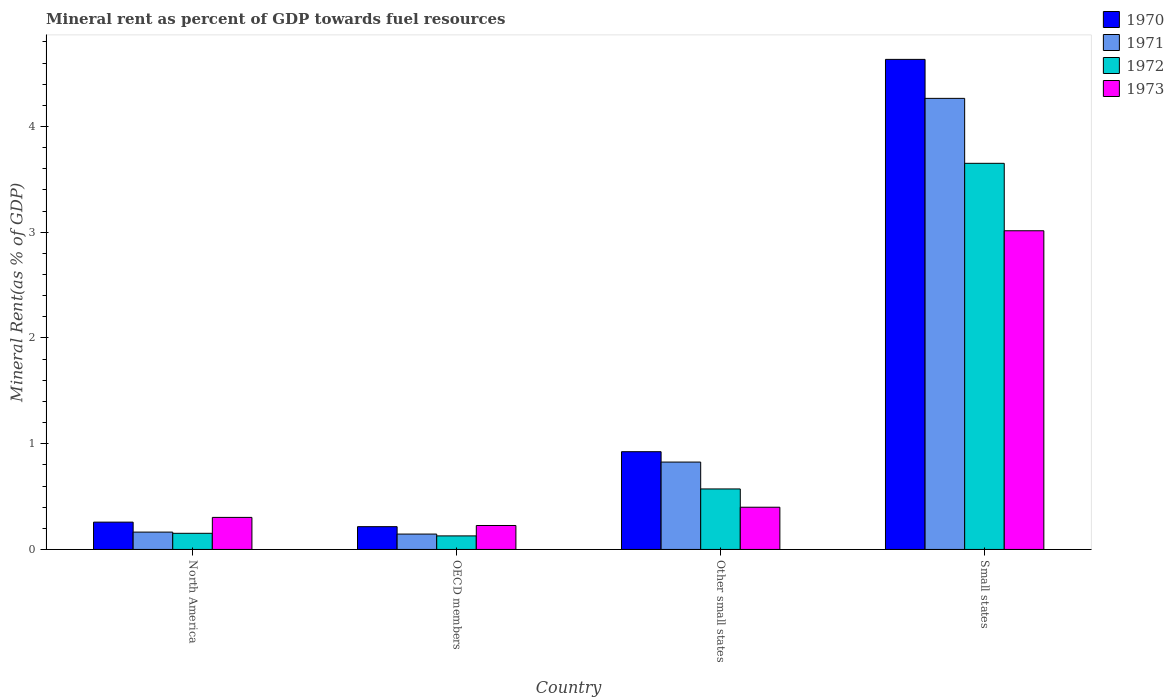How many different coloured bars are there?
Give a very brief answer. 4. How many groups of bars are there?
Provide a short and direct response. 4. Are the number of bars per tick equal to the number of legend labels?
Your answer should be very brief. Yes. How many bars are there on the 4th tick from the right?
Your response must be concise. 4. What is the label of the 1st group of bars from the left?
Provide a succinct answer. North America. In how many cases, is the number of bars for a given country not equal to the number of legend labels?
Provide a short and direct response. 0. What is the mineral rent in 1973 in North America?
Your answer should be very brief. 0.3. Across all countries, what is the maximum mineral rent in 1971?
Keep it short and to the point. 4.27. Across all countries, what is the minimum mineral rent in 1972?
Ensure brevity in your answer.  0.13. In which country was the mineral rent in 1971 maximum?
Offer a terse response. Small states. In which country was the mineral rent in 1970 minimum?
Keep it short and to the point. OECD members. What is the total mineral rent in 1972 in the graph?
Make the answer very short. 4.5. What is the difference between the mineral rent in 1971 in OECD members and that in Small states?
Provide a short and direct response. -4.12. What is the difference between the mineral rent in 1973 in North America and the mineral rent in 1971 in OECD members?
Give a very brief answer. 0.16. What is the average mineral rent in 1971 per country?
Offer a very short reply. 1.35. What is the difference between the mineral rent of/in 1972 and mineral rent of/in 1970 in North America?
Ensure brevity in your answer.  -0.11. In how many countries, is the mineral rent in 1971 greater than 1.2 %?
Ensure brevity in your answer.  1. What is the ratio of the mineral rent in 1973 in North America to that in Small states?
Your answer should be very brief. 0.1. Is the mineral rent in 1970 in North America less than that in OECD members?
Your answer should be compact. No. Is the difference between the mineral rent in 1972 in OECD members and Small states greater than the difference between the mineral rent in 1970 in OECD members and Small states?
Your answer should be very brief. Yes. What is the difference between the highest and the second highest mineral rent in 1971?
Keep it short and to the point. 0.66. What is the difference between the highest and the lowest mineral rent in 1973?
Your response must be concise. 2.79. Is the sum of the mineral rent in 1971 in OECD members and Small states greater than the maximum mineral rent in 1972 across all countries?
Provide a short and direct response. Yes. Is it the case that in every country, the sum of the mineral rent in 1973 and mineral rent in 1970 is greater than the sum of mineral rent in 1971 and mineral rent in 1972?
Provide a short and direct response. No. Is it the case that in every country, the sum of the mineral rent in 1972 and mineral rent in 1971 is greater than the mineral rent in 1973?
Give a very brief answer. Yes. Are all the bars in the graph horizontal?
Make the answer very short. No. How many countries are there in the graph?
Give a very brief answer. 4. What is the difference between two consecutive major ticks on the Y-axis?
Provide a short and direct response. 1. Are the values on the major ticks of Y-axis written in scientific E-notation?
Ensure brevity in your answer.  No. Does the graph contain any zero values?
Your answer should be compact. No. Does the graph contain grids?
Keep it short and to the point. No. What is the title of the graph?
Ensure brevity in your answer.  Mineral rent as percent of GDP towards fuel resources. Does "1962" appear as one of the legend labels in the graph?
Keep it short and to the point. No. What is the label or title of the X-axis?
Provide a succinct answer. Country. What is the label or title of the Y-axis?
Keep it short and to the point. Mineral Rent(as % of GDP). What is the Mineral Rent(as % of GDP) of 1970 in North America?
Provide a short and direct response. 0.26. What is the Mineral Rent(as % of GDP) of 1971 in North America?
Your response must be concise. 0.16. What is the Mineral Rent(as % of GDP) in 1972 in North America?
Your answer should be compact. 0.15. What is the Mineral Rent(as % of GDP) of 1973 in North America?
Provide a short and direct response. 0.3. What is the Mineral Rent(as % of GDP) in 1970 in OECD members?
Make the answer very short. 0.22. What is the Mineral Rent(as % of GDP) of 1971 in OECD members?
Ensure brevity in your answer.  0.15. What is the Mineral Rent(as % of GDP) in 1972 in OECD members?
Your answer should be very brief. 0.13. What is the Mineral Rent(as % of GDP) in 1973 in OECD members?
Provide a succinct answer. 0.23. What is the Mineral Rent(as % of GDP) of 1970 in Other small states?
Offer a terse response. 0.92. What is the Mineral Rent(as % of GDP) of 1971 in Other small states?
Keep it short and to the point. 0.83. What is the Mineral Rent(as % of GDP) of 1972 in Other small states?
Provide a succinct answer. 0.57. What is the Mineral Rent(as % of GDP) of 1973 in Other small states?
Give a very brief answer. 0.4. What is the Mineral Rent(as % of GDP) in 1970 in Small states?
Your answer should be very brief. 4.63. What is the Mineral Rent(as % of GDP) of 1971 in Small states?
Ensure brevity in your answer.  4.27. What is the Mineral Rent(as % of GDP) in 1972 in Small states?
Your answer should be very brief. 3.65. What is the Mineral Rent(as % of GDP) of 1973 in Small states?
Ensure brevity in your answer.  3.01. Across all countries, what is the maximum Mineral Rent(as % of GDP) in 1970?
Make the answer very short. 4.63. Across all countries, what is the maximum Mineral Rent(as % of GDP) of 1971?
Keep it short and to the point. 4.27. Across all countries, what is the maximum Mineral Rent(as % of GDP) in 1972?
Your response must be concise. 3.65. Across all countries, what is the maximum Mineral Rent(as % of GDP) of 1973?
Provide a short and direct response. 3.01. Across all countries, what is the minimum Mineral Rent(as % of GDP) of 1970?
Your answer should be very brief. 0.22. Across all countries, what is the minimum Mineral Rent(as % of GDP) of 1971?
Provide a short and direct response. 0.15. Across all countries, what is the minimum Mineral Rent(as % of GDP) in 1972?
Give a very brief answer. 0.13. Across all countries, what is the minimum Mineral Rent(as % of GDP) in 1973?
Provide a short and direct response. 0.23. What is the total Mineral Rent(as % of GDP) of 1970 in the graph?
Your answer should be very brief. 6.03. What is the total Mineral Rent(as % of GDP) in 1971 in the graph?
Provide a short and direct response. 5.4. What is the total Mineral Rent(as % of GDP) of 1972 in the graph?
Your answer should be compact. 4.5. What is the total Mineral Rent(as % of GDP) in 1973 in the graph?
Your answer should be compact. 3.94. What is the difference between the Mineral Rent(as % of GDP) of 1970 in North America and that in OECD members?
Your response must be concise. 0.04. What is the difference between the Mineral Rent(as % of GDP) in 1971 in North America and that in OECD members?
Offer a very short reply. 0.02. What is the difference between the Mineral Rent(as % of GDP) of 1972 in North America and that in OECD members?
Give a very brief answer. 0.02. What is the difference between the Mineral Rent(as % of GDP) of 1973 in North America and that in OECD members?
Your answer should be very brief. 0.08. What is the difference between the Mineral Rent(as % of GDP) of 1970 in North America and that in Other small states?
Make the answer very short. -0.67. What is the difference between the Mineral Rent(as % of GDP) in 1971 in North America and that in Other small states?
Give a very brief answer. -0.66. What is the difference between the Mineral Rent(as % of GDP) in 1972 in North America and that in Other small states?
Provide a short and direct response. -0.42. What is the difference between the Mineral Rent(as % of GDP) in 1973 in North America and that in Other small states?
Ensure brevity in your answer.  -0.1. What is the difference between the Mineral Rent(as % of GDP) of 1970 in North America and that in Small states?
Provide a short and direct response. -4.38. What is the difference between the Mineral Rent(as % of GDP) in 1971 in North America and that in Small states?
Give a very brief answer. -4.1. What is the difference between the Mineral Rent(as % of GDP) of 1972 in North America and that in Small states?
Keep it short and to the point. -3.5. What is the difference between the Mineral Rent(as % of GDP) in 1973 in North America and that in Small states?
Provide a succinct answer. -2.71. What is the difference between the Mineral Rent(as % of GDP) of 1970 in OECD members and that in Other small states?
Your answer should be compact. -0.71. What is the difference between the Mineral Rent(as % of GDP) in 1971 in OECD members and that in Other small states?
Offer a very short reply. -0.68. What is the difference between the Mineral Rent(as % of GDP) in 1972 in OECD members and that in Other small states?
Your answer should be very brief. -0.44. What is the difference between the Mineral Rent(as % of GDP) of 1973 in OECD members and that in Other small states?
Make the answer very short. -0.17. What is the difference between the Mineral Rent(as % of GDP) of 1970 in OECD members and that in Small states?
Provide a succinct answer. -4.42. What is the difference between the Mineral Rent(as % of GDP) of 1971 in OECD members and that in Small states?
Ensure brevity in your answer.  -4.12. What is the difference between the Mineral Rent(as % of GDP) of 1972 in OECD members and that in Small states?
Offer a terse response. -3.52. What is the difference between the Mineral Rent(as % of GDP) in 1973 in OECD members and that in Small states?
Give a very brief answer. -2.79. What is the difference between the Mineral Rent(as % of GDP) in 1970 in Other small states and that in Small states?
Offer a very short reply. -3.71. What is the difference between the Mineral Rent(as % of GDP) in 1971 in Other small states and that in Small states?
Offer a terse response. -3.44. What is the difference between the Mineral Rent(as % of GDP) in 1972 in Other small states and that in Small states?
Your answer should be compact. -3.08. What is the difference between the Mineral Rent(as % of GDP) of 1973 in Other small states and that in Small states?
Your answer should be compact. -2.61. What is the difference between the Mineral Rent(as % of GDP) of 1970 in North America and the Mineral Rent(as % of GDP) of 1971 in OECD members?
Your answer should be compact. 0.11. What is the difference between the Mineral Rent(as % of GDP) in 1970 in North America and the Mineral Rent(as % of GDP) in 1972 in OECD members?
Give a very brief answer. 0.13. What is the difference between the Mineral Rent(as % of GDP) in 1970 in North America and the Mineral Rent(as % of GDP) in 1973 in OECD members?
Your response must be concise. 0.03. What is the difference between the Mineral Rent(as % of GDP) in 1971 in North America and the Mineral Rent(as % of GDP) in 1972 in OECD members?
Your response must be concise. 0.04. What is the difference between the Mineral Rent(as % of GDP) of 1971 in North America and the Mineral Rent(as % of GDP) of 1973 in OECD members?
Provide a short and direct response. -0.06. What is the difference between the Mineral Rent(as % of GDP) in 1972 in North America and the Mineral Rent(as % of GDP) in 1973 in OECD members?
Your answer should be compact. -0.07. What is the difference between the Mineral Rent(as % of GDP) of 1970 in North America and the Mineral Rent(as % of GDP) of 1971 in Other small states?
Make the answer very short. -0.57. What is the difference between the Mineral Rent(as % of GDP) in 1970 in North America and the Mineral Rent(as % of GDP) in 1972 in Other small states?
Provide a succinct answer. -0.31. What is the difference between the Mineral Rent(as % of GDP) of 1970 in North America and the Mineral Rent(as % of GDP) of 1973 in Other small states?
Provide a short and direct response. -0.14. What is the difference between the Mineral Rent(as % of GDP) of 1971 in North America and the Mineral Rent(as % of GDP) of 1972 in Other small states?
Offer a terse response. -0.41. What is the difference between the Mineral Rent(as % of GDP) of 1971 in North America and the Mineral Rent(as % of GDP) of 1973 in Other small states?
Ensure brevity in your answer.  -0.24. What is the difference between the Mineral Rent(as % of GDP) in 1972 in North America and the Mineral Rent(as % of GDP) in 1973 in Other small states?
Your response must be concise. -0.25. What is the difference between the Mineral Rent(as % of GDP) of 1970 in North America and the Mineral Rent(as % of GDP) of 1971 in Small states?
Keep it short and to the point. -4.01. What is the difference between the Mineral Rent(as % of GDP) in 1970 in North America and the Mineral Rent(as % of GDP) in 1972 in Small states?
Your answer should be very brief. -3.39. What is the difference between the Mineral Rent(as % of GDP) in 1970 in North America and the Mineral Rent(as % of GDP) in 1973 in Small states?
Your answer should be compact. -2.76. What is the difference between the Mineral Rent(as % of GDP) in 1971 in North America and the Mineral Rent(as % of GDP) in 1972 in Small states?
Make the answer very short. -3.49. What is the difference between the Mineral Rent(as % of GDP) of 1971 in North America and the Mineral Rent(as % of GDP) of 1973 in Small states?
Keep it short and to the point. -2.85. What is the difference between the Mineral Rent(as % of GDP) of 1972 in North America and the Mineral Rent(as % of GDP) of 1973 in Small states?
Offer a very short reply. -2.86. What is the difference between the Mineral Rent(as % of GDP) in 1970 in OECD members and the Mineral Rent(as % of GDP) in 1971 in Other small states?
Ensure brevity in your answer.  -0.61. What is the difference between the Mineral Rent(as % of GDP) of 1970 in OECD members and the Mineral Rent(as % of GDP) of 1972 in Other small states?
Keep it short and to the point. -0.36. What is the difference between the Mineral Rent(as % of GDP) of 1970 in OECD members and the Mineral Rent(as % of GDP) of 1973 in Other small states?
Your answer should be compact. -0.18. What is the difference between the Mineral Rent(as % of GDP) of 1971 in OECD members and the Mineral Rent(as % of GDP) of 1972 in Other small states?
Keep it short and to the point. -0.43. What is the difference between the Mineral Rent(as % of GDP) of 1971 in OECD members and the Mineral Rent(as % of GDP) of 1973 in Other small states?
Offer a terse response. -0.25. What is the difference between the Mineral Rent(as % of GDP) in 1972 in OECD members and the Mineral Rent(as % of GDP) in 1973 in Other small states?
Provide a short and direct response. -0.27. What is the difference between the Mineral Rent(as % of GDP) of 1970 in OECD members and the Mineral Rent(as % of GDP) of 1971 in Small states?
Offer a very short reply. -4.05. What is the difference between the Mineral Rent(as % of GDP) in 1970 in OECD members and the Mineral Rent(as % of GDP) in 1972 in Small states?
Offer a very short reply. -3.44. What is the difference between the Mineral Rent(as % of GDP) in 1970 in OECD members and the Mineral Rent(as % of GDP) in 1973 in Small states?
Your answer should be compact. -2.8. What is the difference between the Mineral Rent(as % of GDP) in 1971 in OECD members and the Mineral Rent(as % of GDP) in 1972 in Small states?
Provide a short and direct response. -3.51. What is the difference between the Mineral Rent(as % of GDP) in 1971 in OECD members and the Mineral Rent(as % of GDP) in 1973 in Small states?
Your answer should be very brief. -2.87. What is the difference between the Mineral Rent(as % of GDP) in 1972 in OECD members and the Mineral Rent(as % of GDP) in 1973 in Small states?
Your answer should be very brief. -2.89. What is the difference between the Mineral Rent(as % of GDP) in 1970 in Other small states and the Mineral Rent(as % of GDP) in 1971 in Small states?
Keep it short and to the point. -3.34. What is the difference between the Mineral Rent(as % of GDP) of 1970 in Other small states and the Mineral Rent(as % of GDP) of 1972 in Small states?
Give a very brief answer. -2.73. What is the difference between the Mineral Rent(as % of GDP) of 1970 in Other small states and the Mineral Rent(as % of GDP) of 1973 in Small states?
Offer a very short reply. -2.09. What is the difference between the Mineral Rent(as % of GDP) in 1971 in Other small states and the Mineral Rent(as % of GDP) in 1972 in Small states?
Your answer should be very brief. -2.83. What is the difference between the Mineral Rent(as % of GDP) of 1971 in Other small states and the Mineral Rent(as % of GDP) of 1973 in Small states?
Give a very brief answer. -2.19. What is the difference between the Mineral Rent(as % of GDP) of 1972 in Other small states and the Mineral Rent(as % of GDP) of 1973 in Small states?
Your answer should be compact. -2.44. What is the average Mineral Rent(as % of GDP) in 1970 per country?
Provide a succinct answer. 1.51. What is the average Mineral Rent(as % of GDP) of 1971 per country?
Provide a short and direct response. 1.35. What is the average Mineral Rent(as % of GDP) in 1972 per country?
Ensure brevity in your answer.  1.13. What is the average Mineral Rent(as % of GDP) of 1973 per country?
Ensure brevity in your answer.  0.99. What is the difference between the Mineral Rent(as % of GDP) in 1970 and Mineral Rent(as % of GDP) in 1971 in North America?
Ensure brevity in your answer.  0.09. What is the difference between the Mineral Rent(as % of GDP) in 1970 and Mineral Rent(as % of GDP) in 1972 in North America?
Keep it short and to the point. 0.11. What is the difference between the Mineral Rent(as % of GDP) in 1970 and Mineral Rent(as % of GDP) in 1973 in North America?
Offer a very short reply. -0.04. What is the difference between the Mineral Rent(as % of GDP) of 1971 and Mineral Rent(as % of GDP) of 1972 in North America?
Offer a terse response. 0.01. What is the difference between the Mineral Rent(as % of GDP) of 1971 and Mineral Rent(as % of GDP) of 1973 in North America?
Your response must be concise. -0.14. What is the difference between the Mineral Rent(as % of GDP) of 1972 and Mineral Rent(as % of GDP) of 1973 in North America?
Provide a succinct answer. -0.15. What is the difference between the Mineral Rent(as % of GDP) in 1970 and Mineral Rent(as % of GDP) in 1971 in OECD members?
Provide a succinct answer. 0.07. What is the difference between the Mineral Rent(as % of GDP) of 1970 and Mineral Rent(as % of GDP) of 1972 in OECD members?
Keep it short and to the point. 0.09. What is the difference between the Mineral Rent(as % of GDP) of 1970 and Mineral Rent(as % of GDP) of 1973 in OECD members?
Your response must be concise. -0.01. What is the difference between the Mineral Rent(as % of GDP) of 1971 and Mineral Rent(as % of GDP) of 1972 in OECD members?
Provide a succinct answer. 0.02. What is the difference between the Mineral Rent(as % of GDP) in 1971 and Mineral Rent(as % of GDP) in 1973 in OECD members?
Keep it short and to the point. -0.08. What is the difference between the Mineral Rent(as % of GDP) of 1972 and Mineral Rent(as % of GDP) of 1973 in OECD members?
Keep it short and to the point. -0.1. What is the difference between the Mineral Rent(as % of GDP) in 1970 and Mineral Rent(as % of GDP) in 1971 in Other small states?
Provide a short and direct response. 0.1. What is the difference between the Mineral Rent(as % of GDP) in 1970 and Mineral Rent(as % of GDP) in 1972 in Other small states?
Offer a very short reply. 0.35. What is the difference between the Mineral Rent(as % of GDP) of 1970 and Mineral Rent(as % of GDP) of 1973 in Other small states?
Your answer should be compact. 0.53. What is the difference between the Mineral Rent(as % of GDP) of 1971 and Mineral Rent(as % of GDP) of 1972 in Other small states?
Make the answer very short. 0.25. What is the difference between the Mineral Rent(as % of GDP) in 1971 and Mineral Rent(as % of GDP) in 1973 in Other small states?
Provide a short and direct response. 0.43. What is the difference between the Mineral Rent(as % of GDP) of 1972 and Mineral Rent(as % of GDP) of 1973 in Other small states?
Your response must be concise. 0.17. What is the difference between the Mineral Rent(as % of GDP) of 1970 and Mineral Rent(as % of GDP) of 1971 in Small states?
Give a very brief answer. 0.37. What is the difference between the Mineral Rent(as % of GDP) of 1970 and Mineral Rent(as % of GDP) of 1972 in Small states?
Your answer should be very brief. 0.98. What is the difference between the Mineral Rent(as % of GDP) in 1970 and Mineral Rent(as % of GDP) in 1973 in Small states?
Make the answer very short. 1.62. What is the difference between the Mineral Rent(as % of GDP) of 1971 and Mineral Rent(as % of GDP) of 1972 in Small states?
Offer a very short reply. 0.61. What is the difference between the Mineral Rent(as % of GDP) in 1971 and Mineral Rent(as % of GDP) in 1973 in Small states?
Make the answer very short. 1.25. What is the difference between the Mineral Rent(as % of GDP) of 1972 and Mineral Rent(as % of GDP) of 1973 in Small states?
Your answer should be compact. 0.64. What is the ratio of the Mineral Rent(as % of GDP) of 1970 in North America to that in OECD members?
Your response must be concise. 1.2. What is the ratio of the Mineral Rent(as % of GDP) in 1971 in North America to that in OECD members?
Make the answer very short. 1.13. What is the ratio of the Mineral Rent(as % of GDP) of 1972 in North America to that in OECD members?
Keep it short and to the point. 1.19. What is the ratio of the Mineral Rent(as % of GDP) of 1973 in North America to that in OECD members?
Keep it short and to the point. 1.34. What is the ratio of the Mineral Rent(as % of GDP) of 1970 in North America to that in Other small states?
Offer a terse response. 0.28. What is the ratio of the Mineral Rent(as % of GDP) in 1971 in North America to that in Other small states?
Offer a terse response. 0.2. What is the ratio of the Mineral Rent(as % of GDP) in 1972 in North America to that in Other small states?
Ensure brevity in your answer.  0.27. What is the ratio of the Mineral Rent(as % of GDP) in 1973 in North America to that in Other small states?
Make the answer very short. 0.76. What is the ratio of the Mineral Rent(as % of GDP) in 1970 in North America to that in Small states?
Your response must be concise. 0.06. What is the ratio of the Mineral Rent(as % of GDP) in 1971 in North America to that in Small states?
Provide a succinct answer. 0.04. What is the ratio of the Mineral Rent(as % of GDP) in 1972 in North America to that in Small states?
Provide a short and direct response. 0.04. What is the ratio of the Mineral Rent(as % of GDP) of 1973 in North America to that in Small states?
Your response must be concise. 0.1. What is the ratio of the Mineral Rent(as % of GDP) in 1970 in OECD members to that in Other small states?
Your answer should be compact. 0.23. What is the ratio of the Mineral Rent(as % of GDP) in 1971 in OECD members to that in Other small states?
Your response must be concise. 0.18. What is the ratio of the Mineral Rent(as % of GDP) of 1972 in OECD members to that in Other small states?
Provide a short and direct response. 0.22. What is the ratio of the Mineral Rent(as % of GDP) of 1973 in OECD members to that in Other small states?
Keep it short and to the point. 0.57. What is the ratio of the Mineral Rent(as % of GDP) in 1970 in OECD members to that in Small states?
Your answer should be compact. 0.05. What is the ratio of the Mineral Rent(as % of GDP) of 1971 in OECD members to that in Small states?
Your answer should be compact. 0.03. What is the ratio of the Mineral Rent(as % of GDP) in 1972 in OECD members to that in Small states?
Your answer should be compact. 0.04. What is the ratio of the Mineral Rent(as % of GDP) in 1973 in OECD members to that in Small states?
Your answer should be very brief. 0.08. What is the ratio of the Mineral Rent(as % of GDP) in 1970 in Other small states to that in Small states?
Offer a terse response. 0.2. What is the ratio of the Mineral Rent(as % of GDP) of 1971 in Other small states to that in Small states?
Your answer should be compact. 0.19. What is the ratio of the Mineral Rent(as % of GDP) of 1972 in Other small states to that in Small states?
Ensure brevity in your answer.  0.16. What is the ratio of the Mineral Rent(as % of GDP) of 1973 in Other small states to that in Small states?
Keep it short and to the point. 0.13. What is the difference between the highest and the second highest Mineral Rent(as % of GDP) in 1970?
Give a very brief answer. 3.71. What is the difference between the highest and the second highest Mineral Rent(as % of GDP) of 1971?
Your response must be concise. 3.44. What is the difference between the highest and the second highest Mineral Rent(as % of GDP) of 1972?
Your answer should be compact. 3.08. What is the difference between the highest and the second highest Mineral Rent(as % of GDP) of 1973?
Ensure brevity in your answer.  2.61. What is the difference between the highest and the lowest Mineral Rent(as % of GDP) in 1970?
Make the answer very short. 4.42. What is the difference between the highest and the lowest Mineral Rent(as % of GDP) of 1971?
Provide a succinct answer. 4.12. What is the difference between the highest and the lowest Mineral Rent(as % of GDP) of 1972?
Your answer should be compact. 3.52. What is the difference between the highest and the lowest Mineral Rent(as % of GDP) in 1973?
Your answer should be very brief. 2.79. 